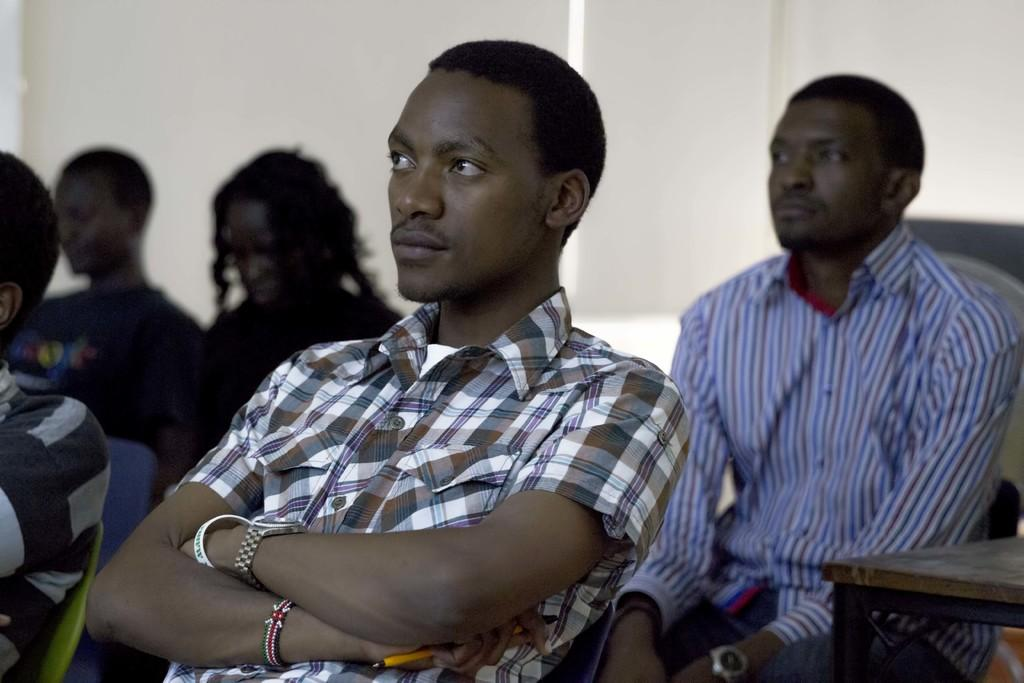What are the people in the image doing? The persons in the image are sitting in chairs. Can you describe the furniture in the image? There is a table in the right corner of the image. What type of recess can be seen in the image? There is no recess present in the image. Can you describe the beetle crawling on the table in the image? There is no beetle present in the image; the only items mentioned are the persons sitting in chairs and the table in the right corner. 